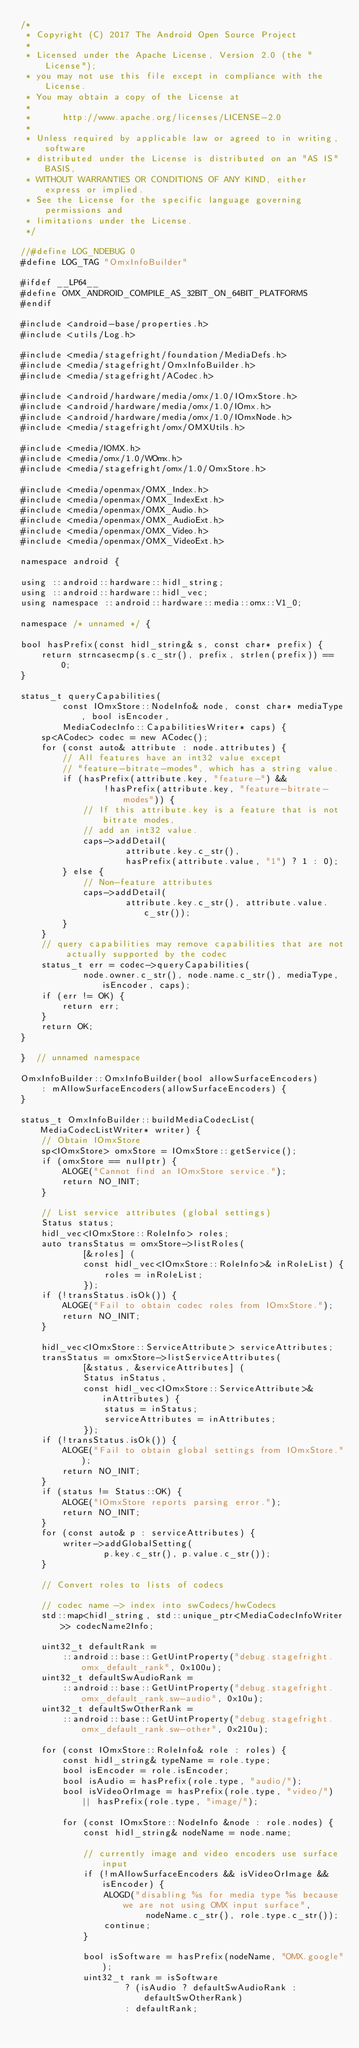<code> <loc_0><loc_0><loc_500><loc_500><_C++_>/*
 * Copyright (C) 2017 The Android Open Source Project
 *
 * Licensed under the Apache License, Version 2.0 (the "License");
 * you may not use this file except in compliance with the License.
 * You may obtain a copy of the License at
 *
 *      http://www.apache.org/licenses/LICENSE-2.0
 *
 * Unless required by applicable law or agreed to in writing, software
 * distributed under the License is distributed on an "AS IS" BASIS,
 * WITHOUT WARRANTIES OR CONDITIONS OF ANY KIND, either express or implied.
 * See the License for the specific language governing permissions and
 * limitations under the License.
 */

//#define LOG_NDEBUG 0
#define LOG_TAG "OmxInfoBuilder"

#ifdef __LP64__
#define OMX_ANDROID_COMPILE_AS_32BIT_ON_64BIT_PLATFORMS
#endif

#include <android-base/properties.h>
#include <utils/Log.h>

#include <media/stagefright/foundation/MediaDefs.h>
#include <media/stagefright/OmxInfoBuilder.h>
#include <media/stagefright/ACodec.h>

#include <android/hardware/media/omx/1.0/IOmxStore.h>
#include <android/hardware/media/omx/1.0/IOmx.h>
#include <android/hardware/media/omx/1.0/IOmxNode.h>
#include <media/stagefright/omx/OMXUtils.h>

#include <media/IOMX.h>
#include <media/omx/1.0/WOmx.h>
#include <media/stagefright/omx/1.0/OmxStore.h>

#include <media/openmax/OMX_Index.h>
#include <media/openmax/OMX_IndexExt.h>
#include <media/openmax/OMX_Audio.h>
#include <media/openmax/OMX_AudioExt.h>
#include <media/openmax/OMX_Video.h>
#include <media/openmax/OMX_VideoExt.h>

namespace android {

using ::android::hardware::hidl_string;
using ::android::hardware::hidl_vec;
using namespace ::android::hardware::media::omx::V1_0;

namespace /* unnamed */ {

bool hasPrefix(const hidl_string& s, const char* prefix) {
    return strncasecmp(s.c_str(), prefix, strlen(prefix)) == 0;
}

status_t queryCapabilities(
        const IOmxStore::NodeInfo& node, const char* mediaType, bool isEncoder,
        MediaCodecInfo::CapabilitiesWriter* caps) {
    sp<ACodec> codec = new ACodec();
    for (const auto& attribute : node.attributes) {
        // All features have an int32 value except
        // "feature-bitrate-modes", which has a string value.
        if (hasPrefix(attribute.key, "feature-") &&
                !hasPrefix(attribute.key, "feature-bitrate-modes")) {
            // If this attribute.key is a feature that is not bitrate modes,
            // add an int32 value.
            caps->addDetail(
                    attribute.key.c_str(),
                    hasPrefix(attribute.value, "1") ? 1 : 0);
        } else {
            // Non-feature attributes
            caps->addDetail(
                    attribute.key.c_str(), attribute.value.c_str());
        }
    }
    // query capabilities may remove capabilities that are not actually supported by the codec
    status_t err = codec->queryCapabilities(
            node.owner.c_str(), node.name.c_str(), mediaType, isEncoder, caps);
    if (err != OK) {
        return err;
    }
    return OK;
}

}  // unnamed namespace

OmxInfoBuilder::OmxInfoBuilder(bool allowSurfaceEncoders)
    : mAllowSurfaceEncoders(allowSurfaceEncoders) {
}

status_t OmxInfoBuilder::buildMediaCodecList(MediaCodecListWriter* writer) {
    // Obtain IOmxStore
    sp<IOmxStore> omxStore = IOmxStore::getService();
    if (omxStore == nullptr) {
        ALOGE("Cannot find an IOmxStore service.");
        return NO_INIT;
    }

    // List service attributes (global settings)
    Status status;
    hidl_vec<IOmxStore::RoleInfo> roles;
    auto transStatus = omxStore->listRoles(
            [&roles] (
            const hidl_vec<IOmxStore::RoleInfo>& inRoleList) {
                roles = inRoleList;
            });
    if (!transStatus.isOk()) {
        ALOGE("Fail to obtain codec roles from IOmxStore.");
        return NO_INIT;
    }

    hidl_vec<IOmxStore::ServiceAttribute> serviceAttributes;
    transStatus = omxStore->listServiceAttributes(
            [&status, &serviceAttributes] (
            Status inStatus,
            const hidl_vec<IOmxStore::ServiceAttribute>& inAttributes) {
                status = inStatus;
                serviceAttributes = inAttributes;
            });
    if (!transStatus.isOk()) {
        ALOGE("Fail to obtain global settings from IOmxStore.");
        return NO_INIT;
    }
    if (status != Status::OK) {
        ALOGE("IOmxStore reports parsing error.");
        return NO_INIT;
    }
    for (const auto& p : serviceAttributes) {
        writer->addGlobalSetting(
                p.key.c_str(), p.value.c_str());
    }

    // Convert roles to lists of codecs

    // codec name -> index into swCodecs/hwCodecs
    std::map<hidl_string, std::unique_ptr<MediaCodecInfoWriter>> codecName2Info;

    uint32_t defaultRank =
        ::android::base::GetUintProperty("debug.stagefright.omx_default_rank", 0x100u);
    uint32_t defaultSwAudioRank =
        ::android::base::GetUintProperty("debug.stagefright.omx_default_rank.sw-audio", 0x10u);
    uint32_t defaultSwOtherRank =
        ::android::base::GetUintProperty("debug.stagefright.omx_default_rank.sw-other", 0x210u);

    for (const IOmxStore::RoleInfo& role : roles) {
        const hidl_string& typeName = role.type;
        bool isEncoder = role.isEncoder;
        bool isAudio = hasPrefix(role.type, "audio/");
        bool isVideoOrImage = hasPrefix(role.type, "video/") || hasPrefix(role.type, "image/");

        for (const IOmxStore::NodeInfo &node : role.nodes) {
            const hidl_string& nodeName = node.name;

            // currently image and video encoders use surface input
            if (!mAllowSurfaceEncoders && isVideoOrImage && isEncoder) {
                ALOGD("disabling %s for media type %s because we are not using OMX input surface",
                        nodeName.c_str(), role.type.c_str());
                continue;
            }

            bool isSoftware = hasPrefix(nodeName, "OMX.google");
            uint32_t rank = isSoftware
                    ? (isAudio ? defaultSwAudioRank : defaultSwOtherRank)
                    : defaultRank;</code> 